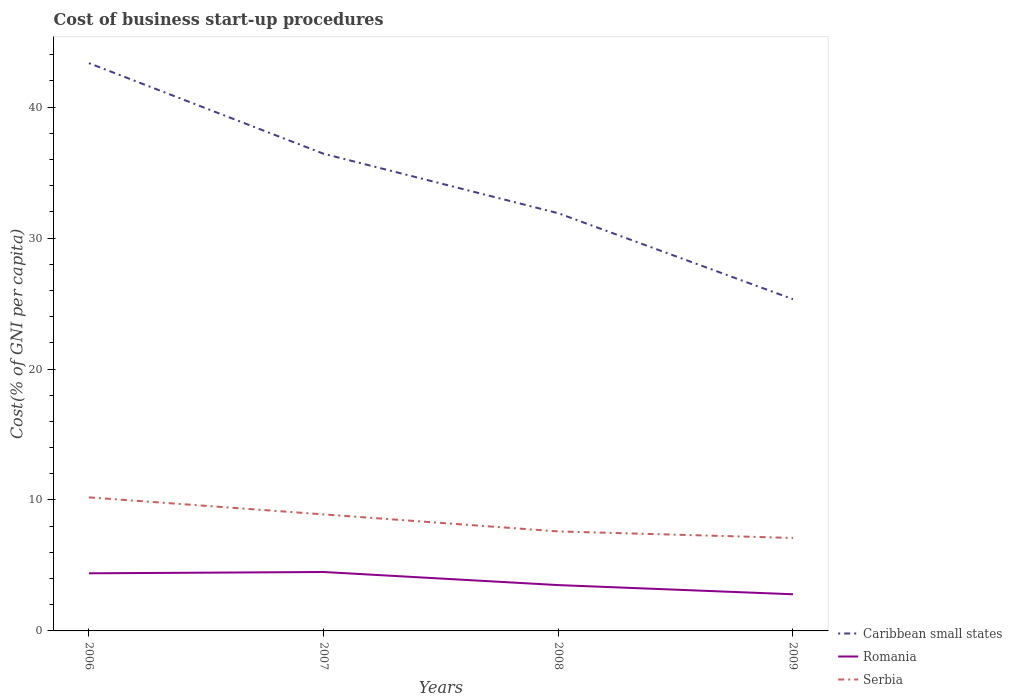Is the number of lines equal to the number of legend labels?
Ensure brevity in your answer.  Yes. What is the total cost of business start-up procedures in Serbia in the graph?
Keep it short and to the point. 3.1. What is the difference between the highest and the second highest cost of business start-up procedures in Caribbean small states?
Ensure brevity in your answer.  18.03. Is the cost of business start-up procedures in Romania strictly greater than the cost of business start-up procedures in Caribbean small states over the years?
Provide a succinct answer. Yes. What is the difference between two consecutive major ticks on the Y-axis?
Provide a succinct answer. 10. Are the values on the major ticks of Y-axis written in scientific E-notation?
Your answer should be very brief. No. Does the graph contain grids?
Keep it short and to the point. No. Where does the legend appear in the graph?
Your answer should be very brief. Bottom right. How many legend labels are there?
Ensure brevity in your answer.  3. How are the legend labels stacked?
Offer a very short reply. Vertical. What is the title of the graph?
Your answer should be very brief. Cost of business start-up procedures. What is the label or title of the Y-axis?
Ensure brevity in your answer.  Cost(% of GNI per capita). What is the Cost(% of GNI per capita) in Caribbean small states in 2006?
Give a very brief answer. 43.36. What is the Cost(% of GNI per capita) in Caribbean small states in 2007?
Make the answer very short. 36.44. What is the Cost(% of GNI per capita) in Caribbean small states in 2008?
Your answer should be very brief. 31.9. What is the Cost(% of GNI per capita) in Caribbean small states in 2009?
Your answer should be very brief. 25.33. What is the Cost(% of GNI per capita) in Romania in 2009?
Provide a succinct answer. 2.8. Across all years, what is the maximum Cost(% of GNI per capita) of Caribbean small states?
Give a very brief answer. 43.36. Across all years, what is the maximum Cost(% of GNI per capita) of Romania?
Offer a terse response. 4.5. Across all years, what is the minimum Cost(% of GNI per capita) in Caribbean small states?
Your answer should be compact. 25.33. Across all years, what is the minimum Cost(% of GNI per capita) of Romania?
Give a very brief answer. 2.8. What is the total Cost(% of GNI per capita) in Caribbean small states in the graph?
Provide a short and direct response. 137.04. What is the total Cost(% of GNI per capita) of Serbia in the graph?
Your answer should be very brief. 33.8. What is the difference between the Cost(% of GNI per capita) in Caribbean small states in 2006 and that in 2007?
Ensure brevity in your answer.  6.92. What is the difference between the Cost(% of GNI per capita) in Caribbean small states in 2006 and that in 2008?
Your answer should be compact. 11.46. What is the difference between the Cost(% of GNI per capita) of Caribbean small states in 2006 and that in 2009?
Ensure brevity in your answer.  18.03. What is the difference between the Cost(% of GNI per capita) of Serbia in 2006 and that in 2009?
Give a very brief answer. 3.1. What is the difference between the Cost(% of GNI per capita) in Caribbean small states in 2007 and that in 2008?
Keep it short and to the point. 4.54. What is the difference between the Cost(% of GNI per capita) in Romania in 2007 and that in 2008?
Keep it short and to the point. 1. What is the difference between the Cost(% of GNI per capita) of Serbia in 2007 and that in 2008?
Make the answer very short. 1.3. What is the difference between the Cost(% of GNI per capita) of Caribbean small states in 2007 and that in 2009?
Provide a succinct answer. 11.11. What is the difference between the Cost(% of GNI per capita) of Caribbean small states in 2008 and that in 2009?
Offer a very short reply. 6.57. What is the difference between the Cost(% of GNI per capita) in Serbia in 2008 and that in 2009?
Provide a succinct answer. 0.5. What is the difference between the Cost(% of GNI per capita) in Caribbean small states in 2006 and the Cost(% of GNI per capita) in Romania in 2007?
Give a very brief answer. 38.86. What is the difference between the Cost(% of GNI per capita) in Caribbean small states in 2006 and the Cost(% of GNI per capita) in Serbia in 2007?
Your answer should be compact. 34.46. What is the difference between the Cost(% of GNI per capita) in Romania in 2006 and the Cost(% of GNI per capita) in Serbia in 2007?
Offer a terse response. -4.5. What is the difference between the Cost(% of GNI per capita) of Caribbean small states in 2006 and the Cost(% of GNI per capita) of Romania in 2008?
Offer a very short reply. 39.86. What is the difference between the Cost(% of GNI per capita) of Caribbean small states in 2006 and the Cost(% of GNI per capita) of Serbia in 2008?
Your answer should be compact. 35.76. What is the difference between the Cost(% of GNI per capita) in Caribbean small states in 2006 and the Cost(% of GNI per capita) in Romania in 2009?
Make the answer very short. 40.56. What is the difference between the Cost(% of GNI per capita) in Caribbean small states in 2006 and the Cost(% of GNI per capita) in Serbia in 2009?
Give a very brief answer. 36.26. What is the difference between the Cost(% of GNI per capita) of Romania in 2006 and the Cost(% of GNI per capita) of Serbia in 2009?
Ensure brevity in your answer.  -2.7. What is the difference between the Cost(% of GNI per capita) of Caribbean small states in 2007 and the Cost(% of GNI per capita) of Romania in 2008?
Offer a terse response. 32.94. What is the difference between the Cost(% of GNI per capita) in Caribbean small states in 2007 and the Cost(% of GNI per capita) in Serbia in 2008?
Your response must be concise. 28.84. What is the difference between the Cost(% of GNI per capita) of Romania in 2007 and the Cost(% of GNI per capita) of Serbia in 2008?
Keep it short and to the point. -3.1. What is the difference between the Cost(% of GNI per capita) in Caribbean small states in 2007 and the Cost(% of GNI per capita) in Romania in 2009?
Give a very brief answer. 33.64. What is the difference between the Cost(% of GNI per capita) in Caribbean small states in 2007 and the Cost(% of GNI per capita) in Serbia in 2009?
Offer a very short reply. 29.34. What is the difference between the Cost(% of GNI per capita) of Caribbean small states in 2008 and the Cost(% of GNI per capita) of Romania in 2009?
Provide a succinct answer. 29.1. What is the difference between the Cost(% of GNI per capita) in Caribbean small states in 2008 and the Cost(% of GNI per capita) in Serbia in 2009?
Provide a short and direct response. 24.8. What is the difference between the Cost(% of GNI per capita) of Romania in 2008 and the Cost(% of GNI per capita) of Serbia in 2009?
Your answer should be very brief. -3.6. What is the average Cost(% of GNI per capita) in Caribbean small states per year?
Your response must be concise. 34.26. What is the average Cost(% of GNI per capita) in Serbia per year?
Your answer should be compact. 8.45. In the year 2006, what is the difference between the Cost(% of GNI per capita) of Caribbean small states and Cost(% of GNI per capita) of Romania?
Offer a very short reply. 38.96. In the year 2006, what is the difference between the Cost(% of GNI per capita) in Caribbean small states and Cost(% of GNI per capita) in Serbia?
Ensure brevity in your answer.  33.16. In the year 2006, what is the difference between the Cost(% of GNI per capita) in Romania and Cost(% of GNI per capita) in Serbia?
Make the answer very short. -5.8. In the year 2007, what is the difference between the Cost(% of GNI per capita) in Caribbean small states and Cost(% of GNI per capita) in Romania?
Your answer should be compact. 31.94. In the year 2007, what is the difference between the Cost(% of GNI per capita) of Caribbean small states and Cost(% of GNI per capita) of Serbia?
Give a very brief answer. 27.54. In the year 2007, what is the difference between the Cost(% of GNI per capita) in Romania and Cost(% of GNI per capita) in Serbia?
Provide a short and direct response. -4.4. In the year 2008, what is the difference between the Cost(% of GNI per capita) of Caribbean small states and Cost(% of GNI per capita) of Romania?
Keep it short and to the point. 28.4. In the year 2008, what is the difference between the Cost(% of GNI per capita) of Caribbean small states and Cost(% of GNI per capita) of Serbia?
Your response must be concise. 24.3. In the year 2009, what is the difference between the Cost(% of GNI per capita) of Caribbean small states and Cost(% of GNI per capita) of Romania?
Your answer should be very brief. 22.53. In the year 2009, what is the difference between the Cost(% of GNI per capita) in Caribbean small states and Cost(% of GNI per capita) in Serbia?
Your answer should be compact. 18.23. In the year 2009, what is the difference between the Cost(% of GNI per capita) of Romania and Cost(% of GNI per capita) of Serbia?
Make the answer very short. -4.3. What is the ratio of the Cost(% of GNI per capita) in Caribbean small states in 2006 to that in 2007?
Provide a short and direct response. 1.19. What is the ratio of the Cost(% of GNI per capita) of Romania in 2006 to that in 2007?
Offer a terse response. 0.98. What is the ratio of the Cost(% of GNI per capita) of Serbia in 2006 to that in 2007?
Give a very brief answer. 1.15. What is the ratio of the Cost(% of GNI per capita) in Caribbean small states in 2006 to that in 2008?
Provide a short and direct response. 1.36. What is the ratio of the Cost(% of GNI per capita) in Romania in 2006 to that in 2008?
Offer a very short reply. 1.26. What is the ratio of the Cost(% of GNI per capita) of Serbia in 2006 to that in 2008?
Your answer should be very brief. 1.34. What is the ratio of the Cost(% of GNI per capita) in Caribbean small states in 2006 to that in 2009?
Make the answer very short. 1.71. What is the ratio of the Cost(% of GNI per capita) in Romania in 2006 to that in 2009?
Keep it short and to the point. 1.57. What is the ratio of the Cost(% of GNI per capita) of Serbia in 2006 to that in 2009?
Provide a succinct answer. 1.44. What is the ratio of the Cost(% of GNI per capita) in Caribbean small states in 2007 to that in 2008?
Ensure brevity in your answer.  1.14. What is the ratio of the Cost(% of GNI per capita) of Romania in 2007 to that in 2008?
Give a very brief answer. 1.29. What is the ratio of the Cost(% of GNI per capita) in Serbia in 2007 to that in 2008?
Make the answer very short. 1.17. What is the ratio of the Cost(% of GNI per capita) in Caribbean small states in 2007 to that in 2009?
Your response must be concise. 1.44. What is the ratio of the Cost(% of GNI per capita) in Romania in 2007 to that in 2009?
Give a very brief answer. 1.61. What is the ratio of the Cost(% of GNI per capita) of Serbia in 2007 to that in 2009?
Keep it short and to the point. 1.25. What is the ratio of the Cost(% of GNI per capita) in Caribbean small states in 2008 to that in 2009?
Provide a succinct answer. 1.26. What is the ratio of the Cost(% of GNI per capita) of Serbia in 2008 to that in 2009?
Provide a succinct answer. 1.07. What is the difference between the highest and the second highest Cost(% of GNI per capita) of Caribbean small states?
Provide a short and direct response. 6.92. What is the difference between the highest and the second highest Cost(% of GNI per capita) of Romania?
Your response must be concise. 0.1. What is the difference between the highest and the second highest Cost(% of GNI per capita) in Serbia?
Provide a short and direct response. 1.3. What is the difference between the highest and the lowest Cost(% of GNI per capita) of Caribbean small states?
Ensure brevity in your answer.  18.03. What is the difference between the highest and the lowest Cost(% of GNI per capita) of Serbia?
Provide a short and direct response. 3.1. 